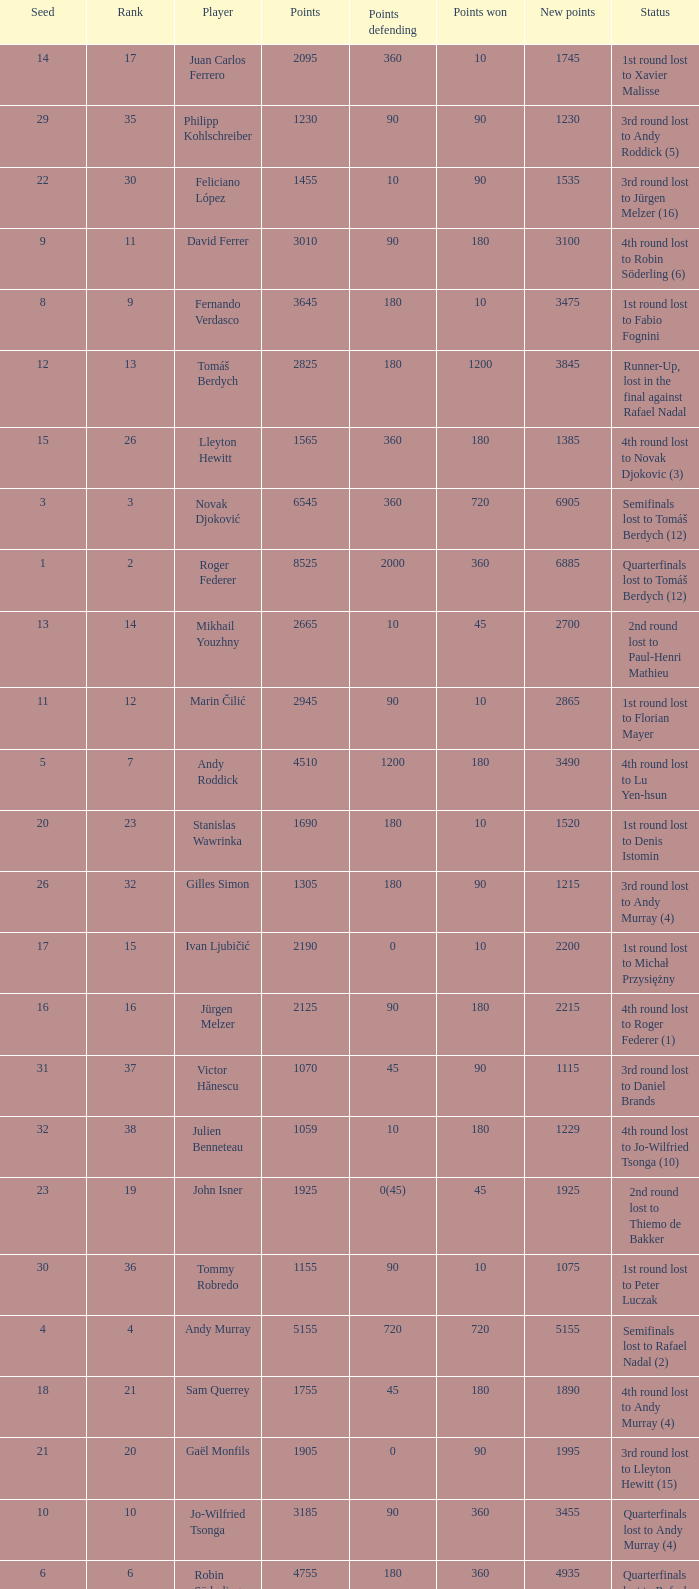Name the status for points 3185 Quarterfinals lost to Andy Murray (4). 